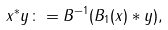Convert formula to latex. <formula><loc_0><loc_0><loc_500><loc_500>x ^ { * } y \colon = B ^ { - 1 } ( B _ { 1 } ( x ) * y ) ,</formula> 